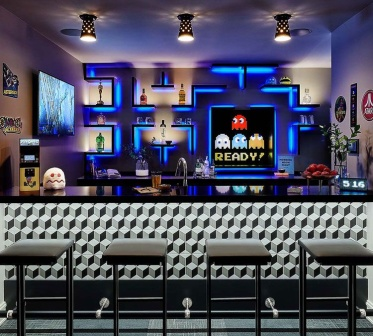Can you create a short story about why this bar has a Pac-Man theme? Once upon a time, a passionate arcade games enthusiast named Jack inherited an old, run-down bar from his grandfather. Determined to revive it, Jack decided to blend his love for classic games with a modern twist. Hence, he transformed the bar with bright neon lights, a black and white checkered floor, and a large screen proclaiming 'PAC-MAN READY!'. The bar quickly became renowned as a nostalgic haven where people could relive their childhood memories while enjoying delicious cocktails, attracting locals and visitors alike. 